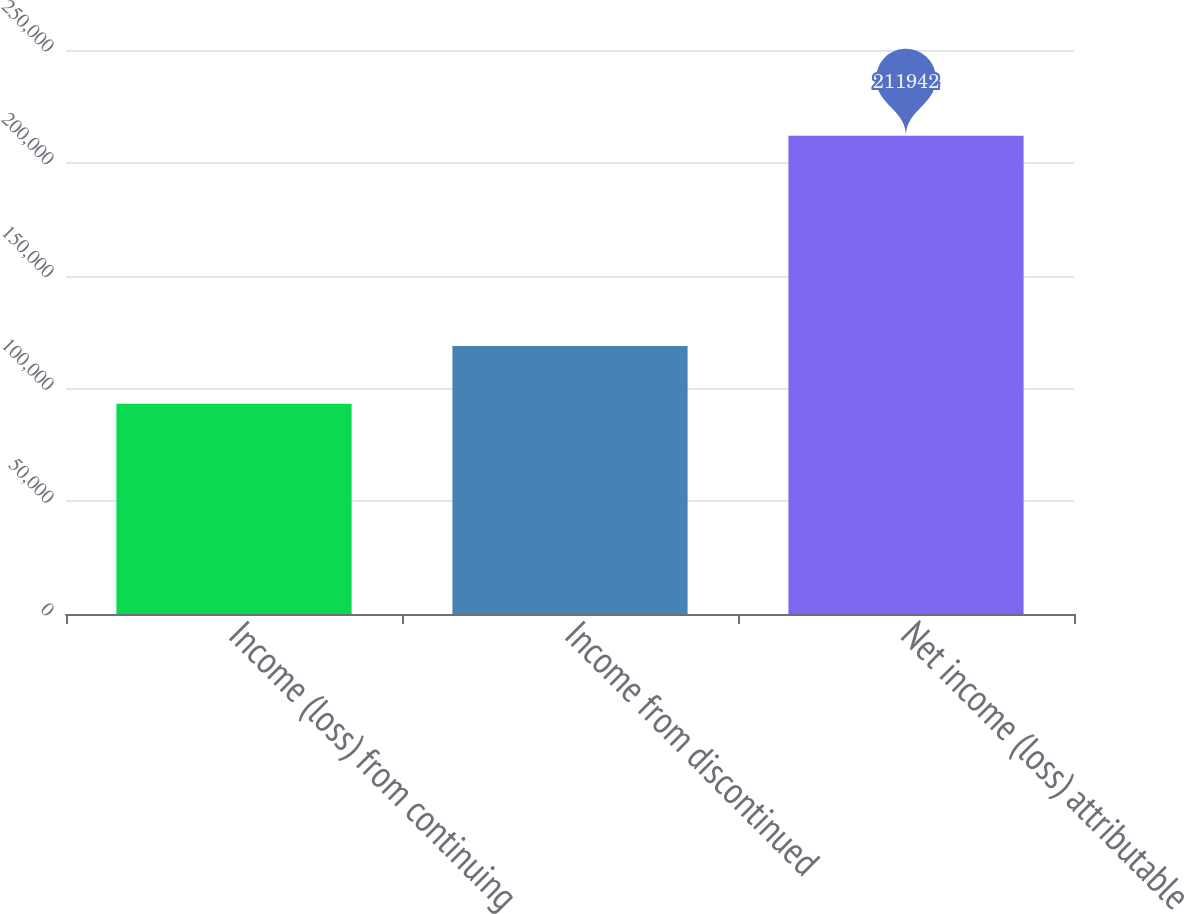Convert chart. <chart><loc_0><loc_0><loc_500><loc_500><bar_chart><fcel>Income (loss) from continuing<fcel>Income from discontinued<fcel>Net income (loss) attributable<nl><fcel>93168<fcel>118774<fcel>211942<nl></chart> 